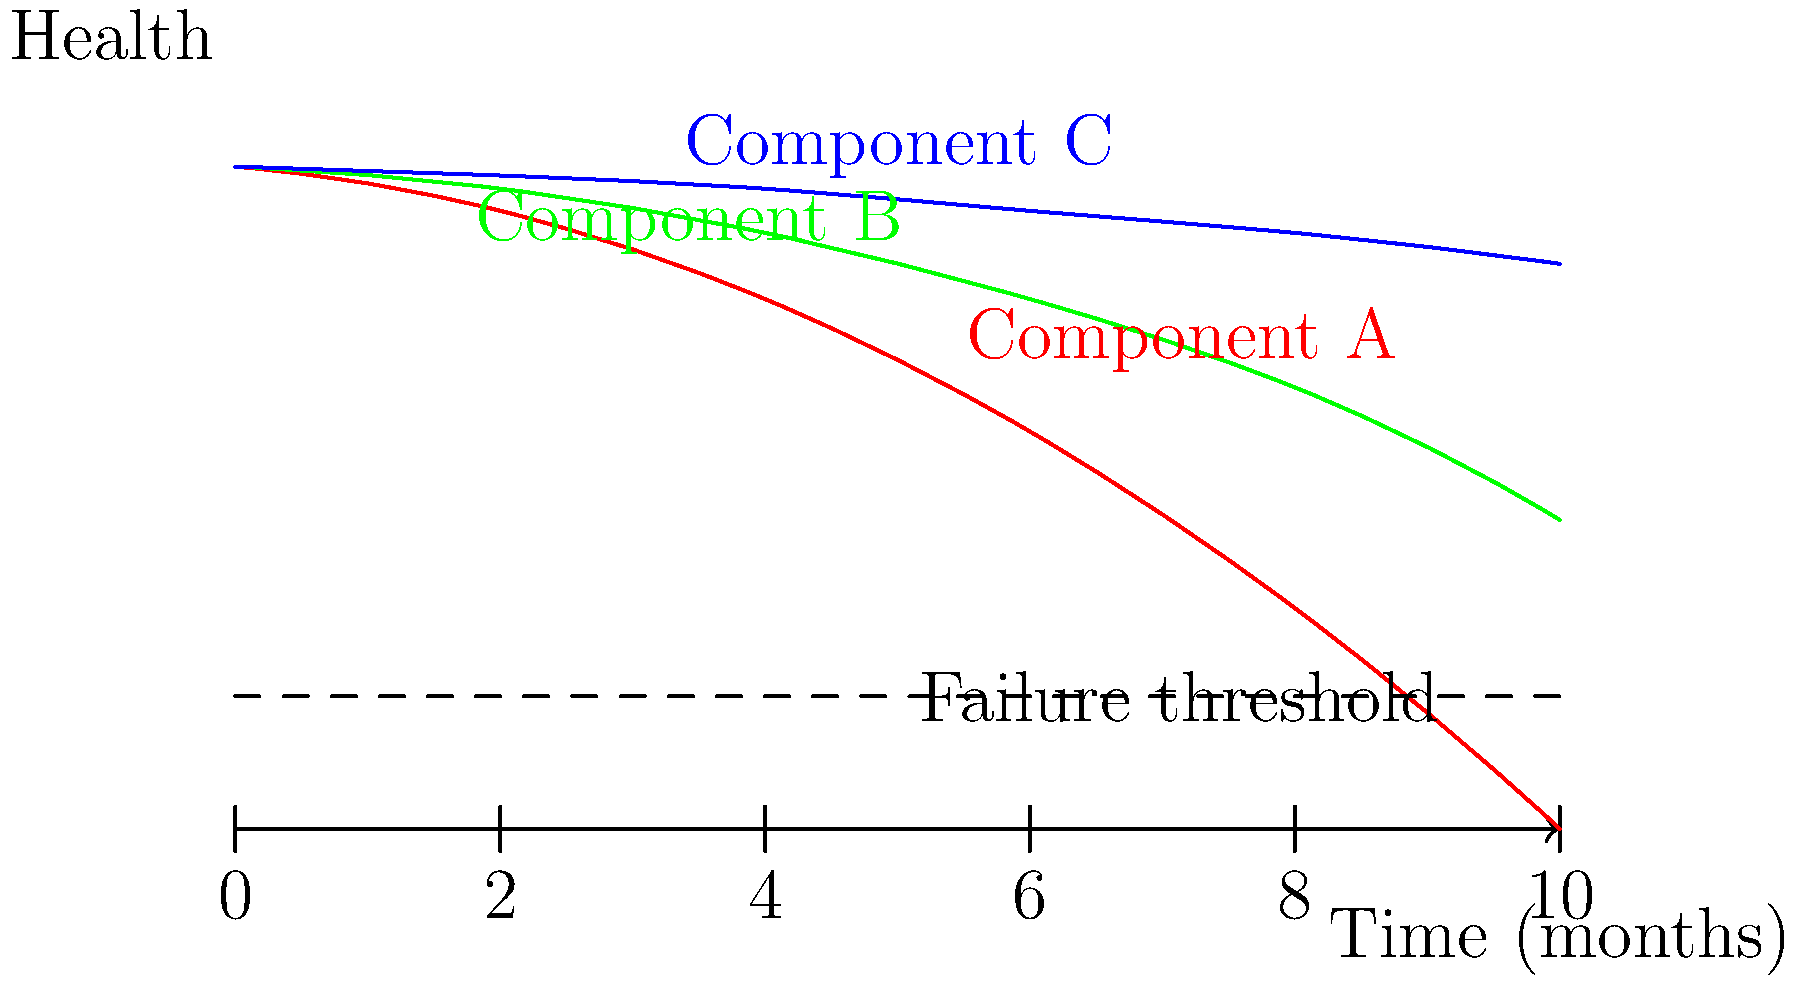Based on the AI-generated predictive maintenance schedule shown in the component diagram, which component should be prioritized for maintenance, and approximately when should this maintenance be scheduled to prevent failure? To answer this question, we need to analyze the graph and interpret the AI-generated predictive maintenance schedule:

1. The graph shows the health of three components (A, B, and C) over time, with a failure threshold indicated by a dashed line.

2. Component A (red line):
   - Starts at the highest health level
   - Declines rapidly over time
   - Crosses the failure threshold at approximately 8-9 months

3. Component B (green line):
   - Starts slightly below Component A
   - Declines more slowly than Component A
   - Does not cross the failure threshold within the 10-month timeframe shown

4. Component C (blue line):
   - Starts slightly below Component B
   - Declines very slowly
   - Maintains the highest health level throughout the timeframe

5. Prioritization:
   - Component A should be prioritized for maintenance as it is the only component predicted to fail within the given timeframe.

6. Maintenance scheduling:
   - To prevent failure, maintenance should be scheduled before Component A crosses the failure threshold.
   - A safe margin would be to schedule maintenance at around 6-7 months, allowing time for planning and preventing any unexpected early failures.

Therefore, Component A should be prioritized, with maintenance scheduled at approximately 6-7 months to prevent failure.
Answer: Component A, at 6-7 months 